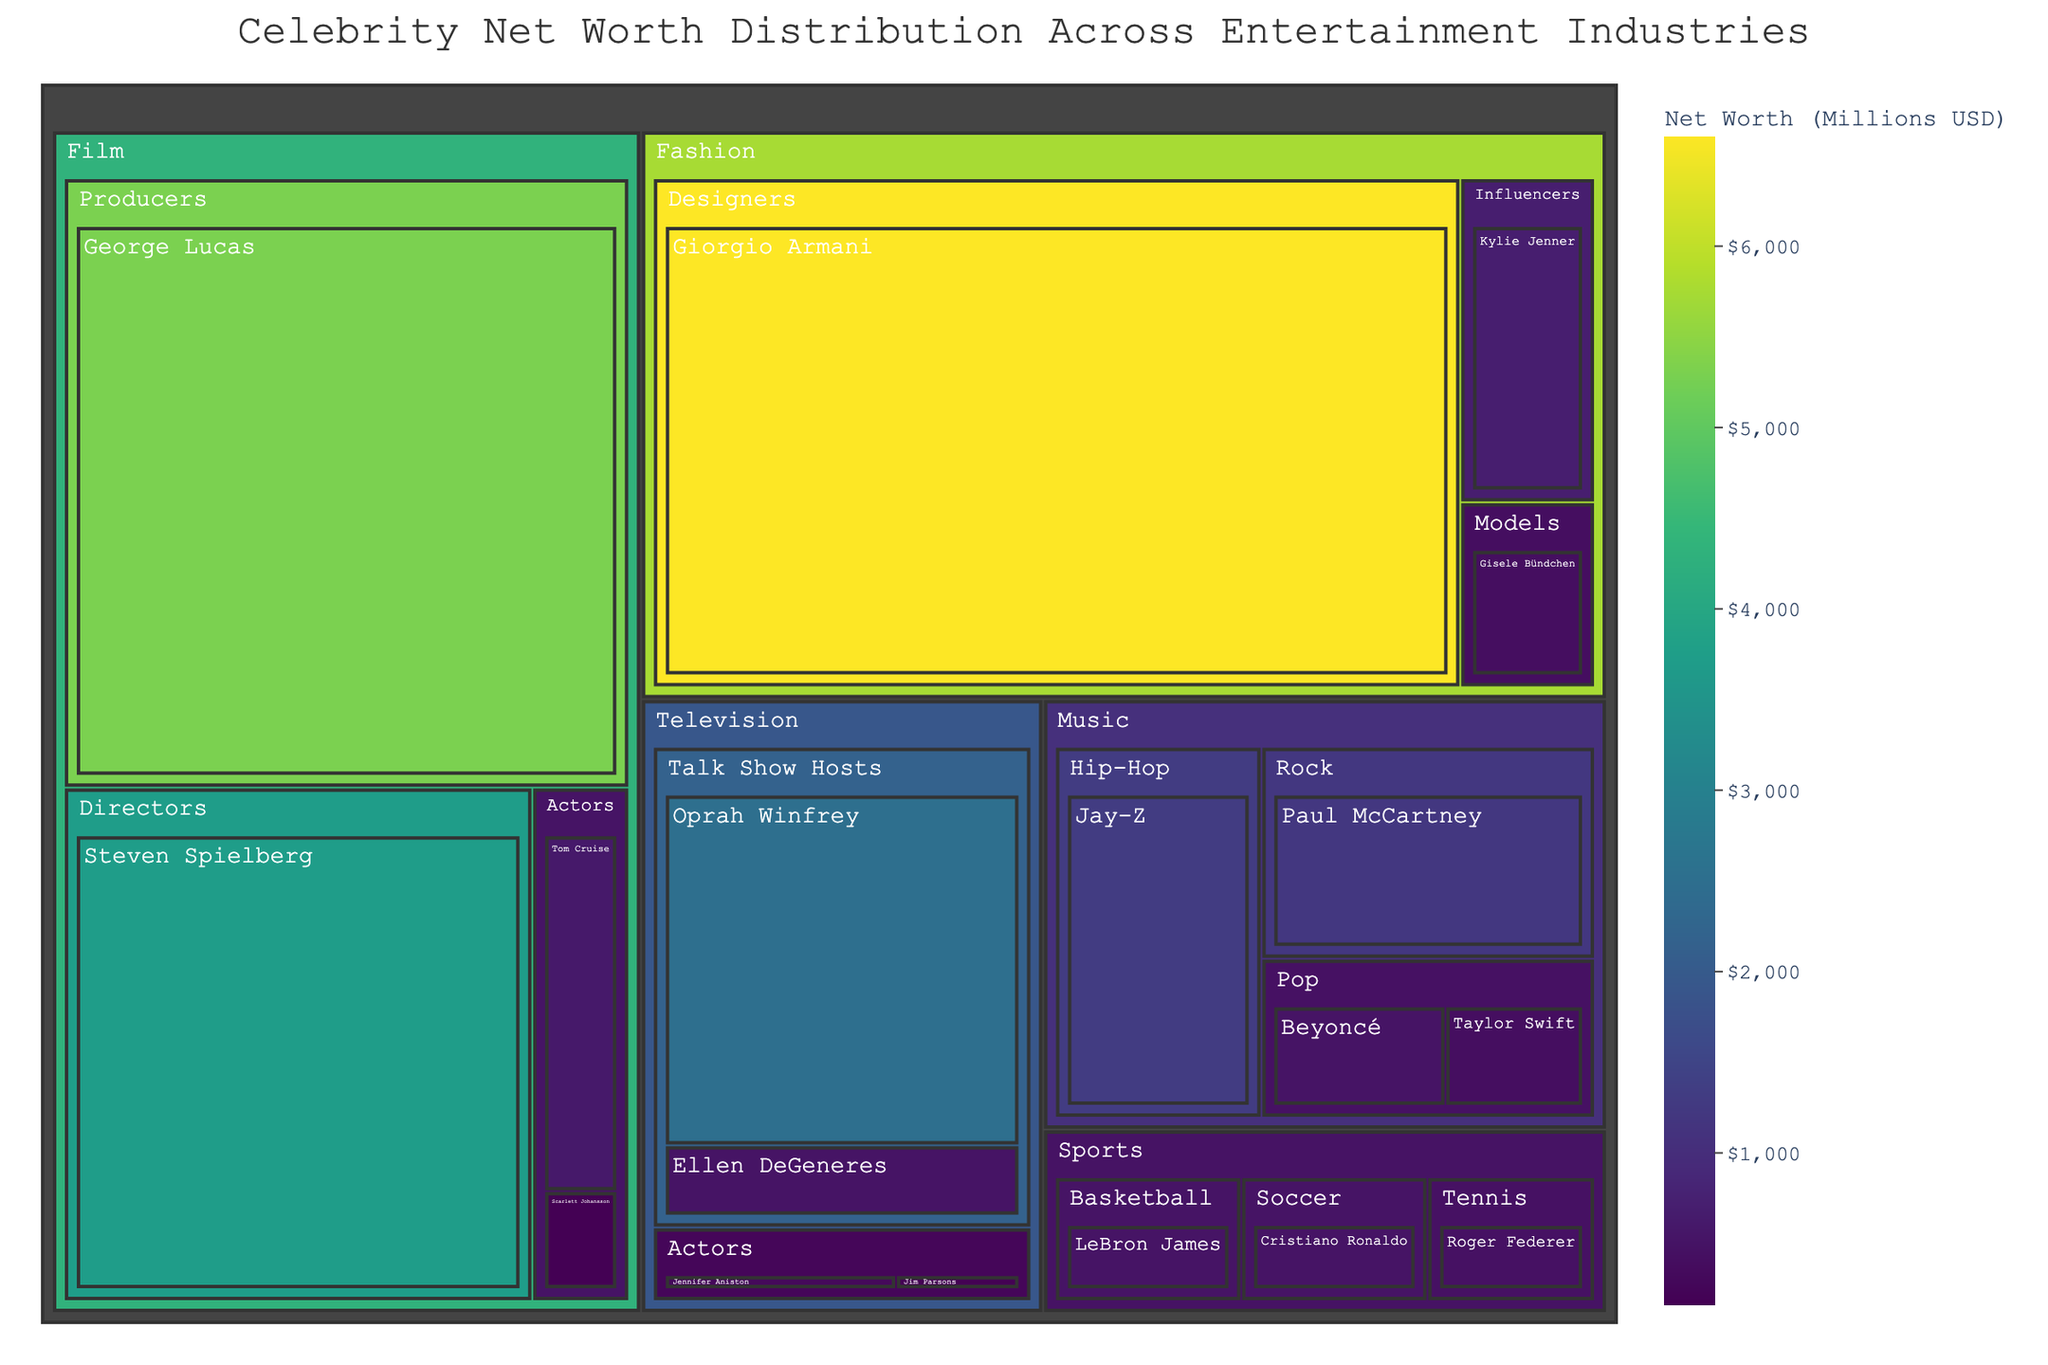What is the title of the treemap? Look at the top of the treemap where the title is usually placed.
Answer: Celebrity Net Worth Distribution Across Entertainment Industries Who is the celebrity with the highest net worth in the Figure? Locate the celebrity with the largest area or the darkest hue in the treemap to identify the highest net worth.
Answer: Giorgio Armani Which industry contains the celebrity with the highest net worth? Find the industry that includes the celebrity with the highest net worth, indicated by the largest block in the figure.
Answer: Fashion What is the combined net worth of all the celebrities in the Music industry? Sum the net worth of Taylor Swift, Beyoncé, Jay-Z, and Paul McCartney.
Answer: $3,400 Million Which category has a higher net worth in the Film industry: Actors or Producers? Compare the net worth values of all the celebrities in the Actors category against those in the Producers category.
Answer: Producers Who has a higher net worth: Oprah Winfrey or Ellen DeGeneres? Compare the net worth values indicated next to Oprah Winfrey and Ellen DeGeneres.
Answer: Oprah Winfrey What is the net worth difference between Steven Spielberg and George Lucas? Subtract Steven Spielberg's net worth from George Lucas's net worth.
Answer: $1,600 Million Which sports celebrity has the highest net worth? Look for the largest or darkest shaded block within the Sports industry section.
Answer: LeBron James How does the net worth of the top Film celebrity compare to the top Television celebrity? Compare the net worth of George Lucas (Film) with Oprah Winfrey (Television).
Answer: George Lucas has more If combining the net worth of Kylie Jenner and Gisele Bündchen, how does it compare to the net worth of Giorgio Armani? Add the net worth of Kylie Jenner and Gisele Bündchen, then compare it to Giorgio Armani.
Answer: Giorgio Armani has more 